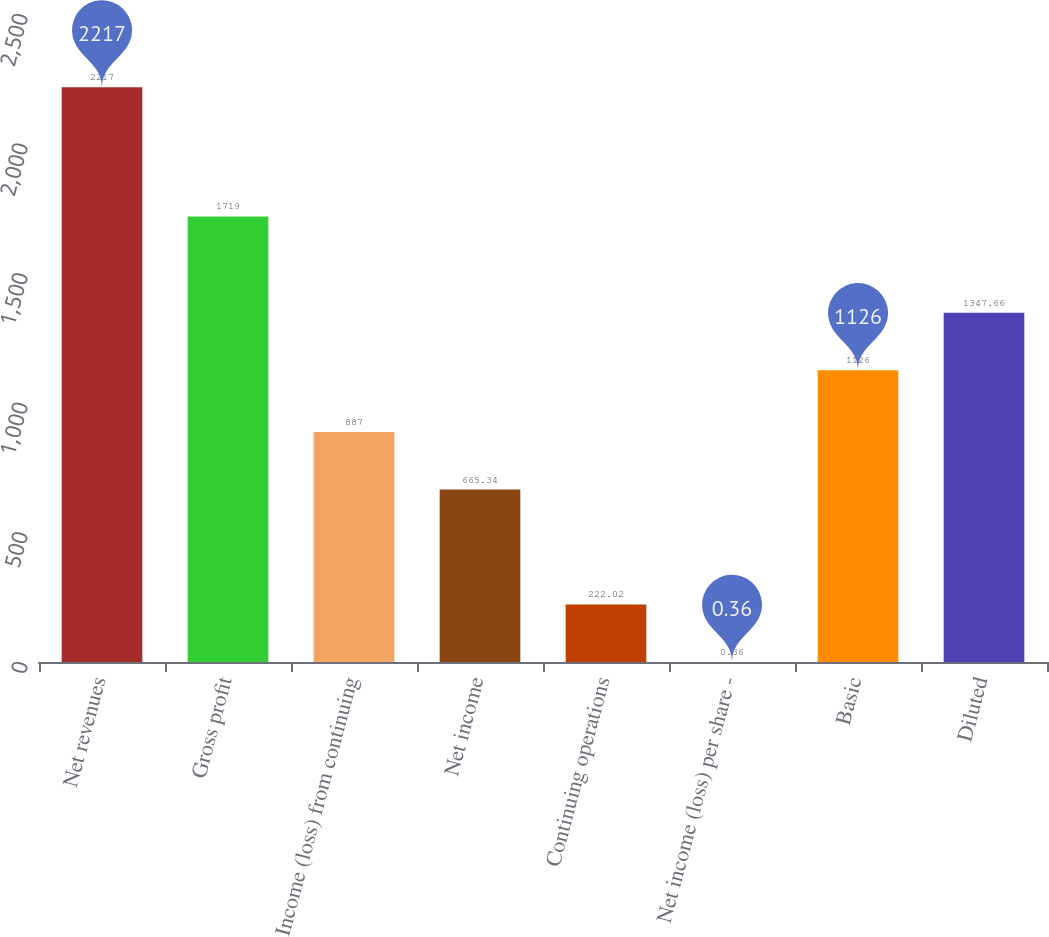Convert chart to OTSL. <chart><loc_0><loc_0><loc_500><loc_500><bar_chart><fcel>Net revenues<fcel>Gross profit<fcel>Income (loss) from continuing<fcel>Net income<fcel>Continuing operations<fcel>Net income (loss) per share -<fcel>Basic<fcel>Diluted<nl><fcel>2217<fcel>1719<fcel>887<fcel>665.34<fcel>222.02<fcel>0.36<fcel>1126<fcel>1347.66<nl></chart> 